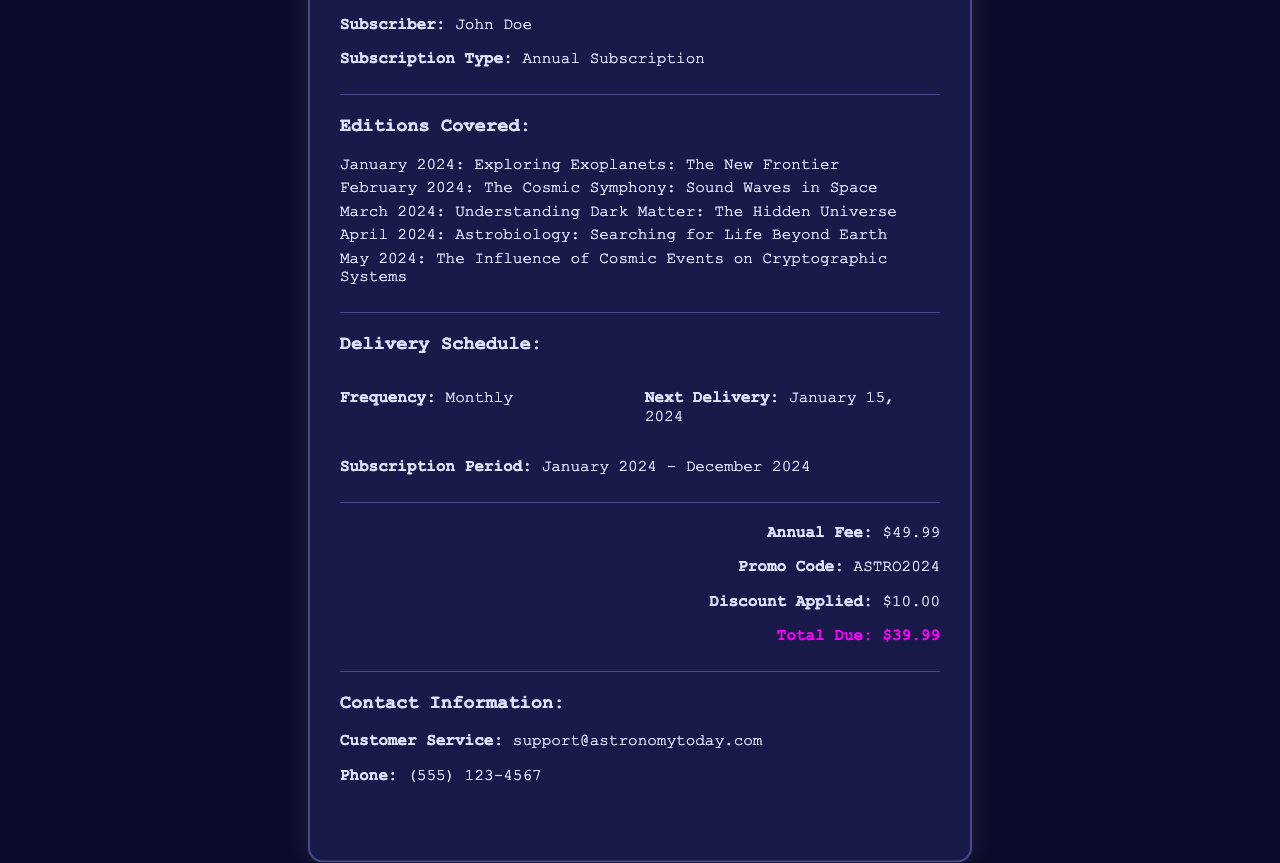What is the name of the magazine? The name of the magazine is provided at the top of the receipt as "Astronomy Today."
Answer: Astronomy Today Who is the subscriber? The subscriber's name is mentioned in the receipt, which is "John Doe."
Answer: John Doe What is the subscription type? The type of subscription is indicated in the receipt as "Annual Subscription."
Answer: Annual Subscription When is the next delivery? The date for the next delivery is listed in the document as "January 15, 2024."
Answer: January 15, 2024 What is the total due amount? The total due amount is highlighted in the receipt as "$39.99."
Answer: $39.99 What editions are covered in May 2024? The edition covered in May 2024 is specified as "The Influence of Cosmic Events on Cryptographic Systems."
Answer: The Influence of Cosmic Events on Cryptographic Systems What is the frequency of delivery? The frequency of delivery is stated in the receipt as "Monthly."
Answer: Monthly What is the annual fee before the discount? The annual fee is clearly stated as "$49.99" before any discounts.
Answer: $49.99 What discount is applied? The amount of discount applied is mentioned in the receipt as "$10.00."
Answer: $10.00 